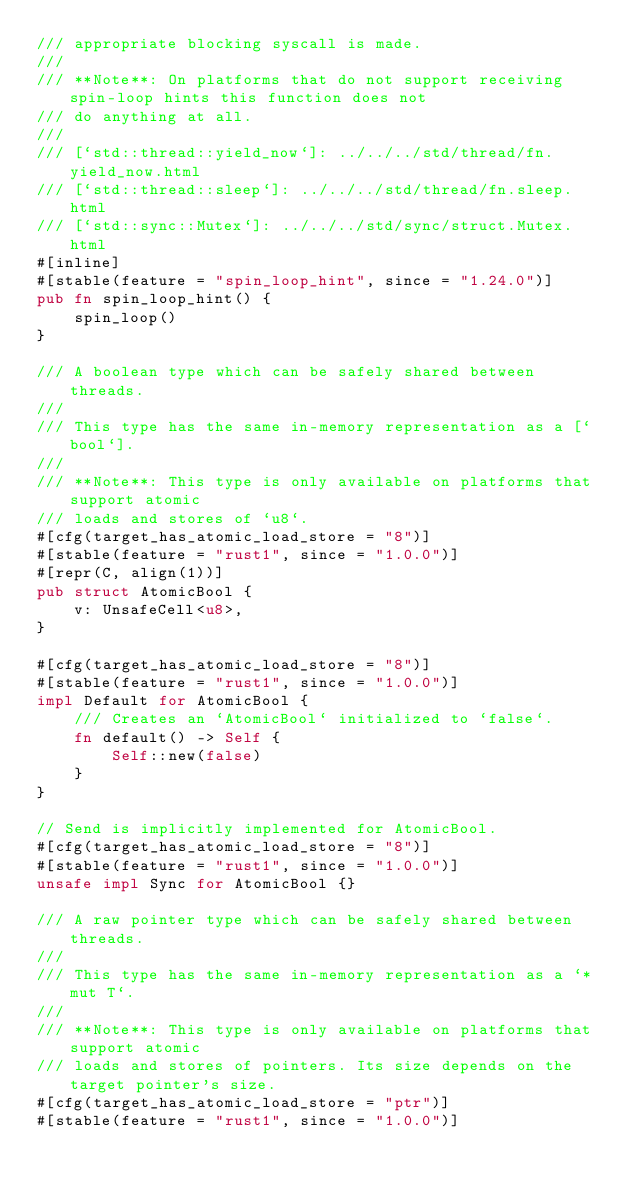Convert code to text. <code><loc_0><loc_0><loc_500><loc_500><_Rust_>/// appropriate blocking syscall is made.
///
/// **Note**: On platforms that do not support receiving spin-loop hints this function does not
/// do anything at all.
///
/// [`std::thread::yield_now`]: ../../../std/thread/fn.yield_now.html
/// [`std::thread::sleep`]: ../../../std/thread/fn.sleep.html
/// [`std::sync::Mutex`]: ../../../std/sync/struct.Mutex.html
#[inline]
#[stable(feature = "spin_loop_hint", since = "1.24.0")]
pub fn spin_loop_hint() {
    spin_loop()
}

/// A boolean type which can be safely shared between threads.
///
/// This type has the same in-memory representation as a [`bool`].
///
/// **Note**: This type is only available on platforms that support atomic
/// loads and stores of `u8`.
#[cfg(target_has_atomic_load_store = "8")]
#[stable(feature = "rust1", since = "1.0.0")]
#[repr(C, align(1))]
pub struct AtomicBool {
    v: UnsafeCell<u8>,
}

#[cfg(target_has_atomic_load_store = "8")]
#[stable(feature = "rust1", since = "1.0.0")]
impl Default for AtomicBool {
    /// Creates an `AtomicBool` initialized to `false`.
    fn default() -> Self {
        Self::new(false)
    }
}

// Send is implicitly implemented for AtomicBool.
#[cfg(target_has_atomic_load_store = "8")]
#[stable(feature = "rust1", since = "1.0.0")]
unsafe impl Sync for AtomicBool {}

/// A raw pointer type which can be safely shared between threads.
///
/// This type has the same in-memory representation as a `*mut T`.
///
/// **Note**: This type is only available on platforms that support atomic
/// loads and stores of pointers. Its size depends on the target pointer's size.
#[cfg(target_has_atomic_load_store = "ptr")]
#[stable(feature = "rust1", since = "1.0.0")]</code> 